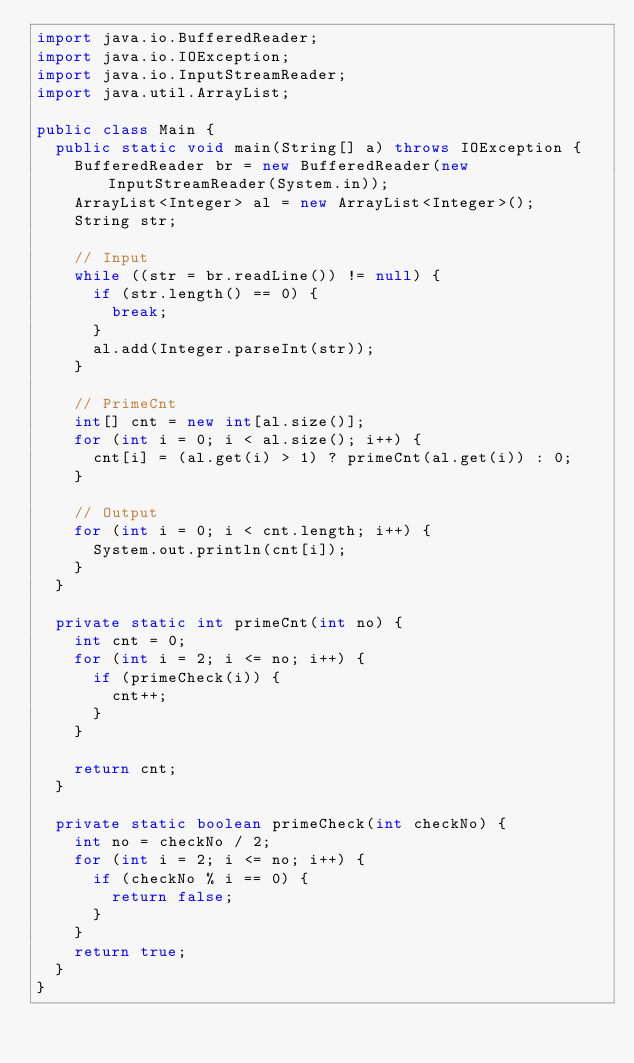Convert code to text. <code><loc_0><loc_0><loc_500><loc_500><_Java_>import java.io.BufferedReader;
import java.io.IOException;
import java.io.InputStreamReader;
import java.util.ArrayList;

public class Main {
	public static void main(String[] a) throws IOException {
		BufferedReader br = new BufferedReader(new InputStreamReader(System.in));
		ArrayList<Integer> al = new ArrayList<Integer>();
		String str;

		// Input
		while ((str = br.readLine()) != null) {
			if (str.length() == 0) {
				break;
			}
			al.add(Integer.parseInt(str));
		}

		// PrimeCnt
		int[] cnt = new int[al.size()];
		for (int i = 0; i < al.size(); i++) {
			cnt[i] = (al.get(i) > 1) ? primeCnt(al.get(i)) : 0;
		}

		// Output
		for (int i = 0; i < cnt.length; i++) {
			System.out.println(cnt[i]);
		}
	}

	private static int primeCnt(int no) {
		int cnt = 0;
		for (int i = 2; i <= no; i++) {
			if (primeCheck(i)) {
				cnt++;
			}
		}

		return cnt;
	}

	private static boolean primeCheck(int checkNo) {
		int no = checkNo / 2;
		for (int i = 2; i <= no; i++) {
			if (checkNo % i == 0) {
				return false;
			}
		}
		return true;
	}
}</code> 